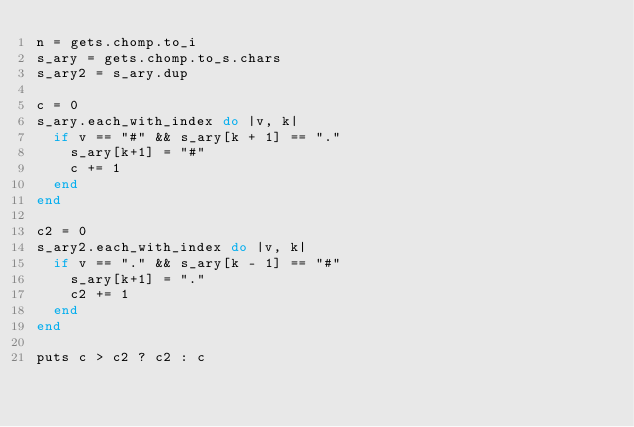Convert code to text. <code><loc_0><loc_0><loc_500><loc_500><_Ruby_>n = gets.chomp.to_i
s_ary = gets.chomp.to_s.chars
s_ary2 = s_ary.dup

c = 0
s_ary.each_with_index do |v, k|
  if v == "#" && s_ary[k + 1] == "."
    s_ary[k+1] = "#"
    c += 1
  end
end

c2 = 0
s_ary2.each_with_index do |v, k|
  if v == "." && s_ary[k - 1] == "#"
    s_ary[k+1] = "."
    c2 += 1
  end
end

puts c > c2 ? c2 : c
</code> 